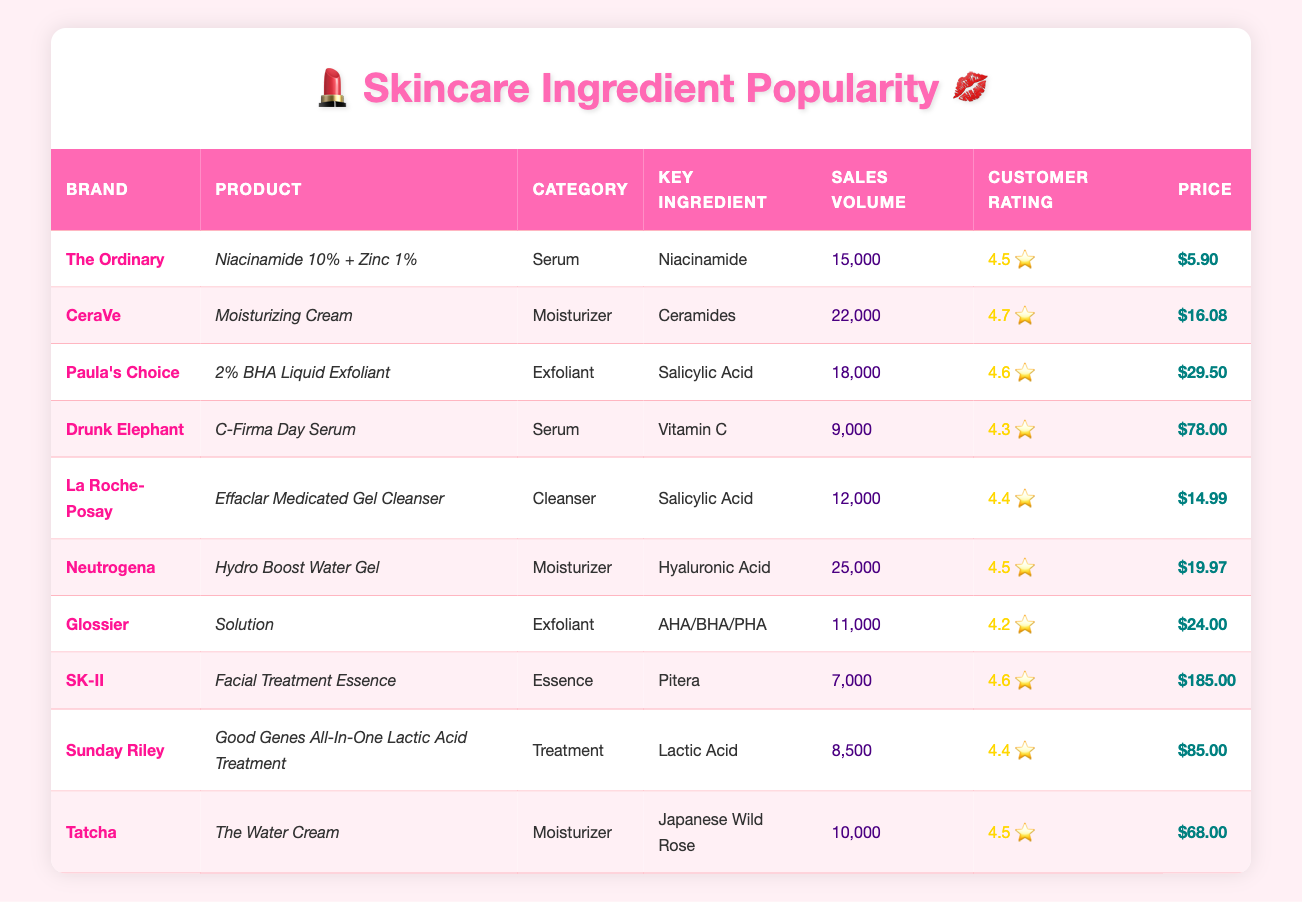What is the highest customer rating among the products listed? The customer ratings listed in the table are 4.5, 4.7, 4.6, 4.3, 4.4, 4.5, 4.2, 4.6, 4.4, and 4.5. The highest of these ratings is 4.7 from CeraVe's Moisturizing Cream.
Answer: 4.7 Which product has the lowest sales volume, and what is it? The sales volumes are 15,000; 22,000; 18,000; 9,000; 12,000; 25,000; 11,000; 7,000; 8,500; and 10,000. The lowest sales volume is 7,000, corresponding to SK-II's Facial Treatment Essence.
Answer: SK-II Facial Treatment Essence What is the average sales volume of all the products? To calculate the average sales volume, sum the sales volumes (15,000 + 22,000 + 18,000 + 9,000 + 12,000 + 25,000 + 11,000 + 7,000 + 8,500 + 10,000 =  127,500) and then divide by the number of products (10). So, 127,500 / 10 = 12,750.
Answer: 12,750 Is there any product with a price above $80? By scanning the price column, we see that the prices are 5.90, 16.08, 29.50, 78.00, 14.99, 19.97, 24.00, 185.00, 85.00, and 68.00. Both SK-II's Facial Treatment Essence and Sunday Riley's treatment are priced above $80.
Answer: Yes How many products contain Salicylic Acid as a key ingredient? In the table, the products with Salicylic Acid are Paula's Choice 2% BHA Liquid Exfoliant and La Roche-Posay Effaclar Medicated Gel Cleanser. Hence, there are 2 products that list Salicylic Acid as the key ingredient.
Answer: 2 